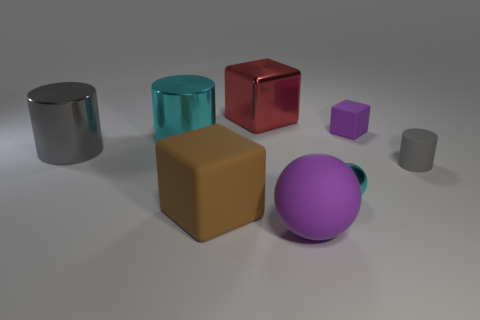Subtract all gray cylinders. How many were subtracted if there are1gray cylinders left? 1 Subtract all cyan cylinders. How many cylinders are left? 2 Subtract all brown spheres. How many gray cylinders are left? 2 Subtract all cyan cylinders. How many cylinders are left? 2 Add 2 tiny cyan cylinders. How many objects exist? 10 Subtract 1 cubes. How many cubes are left? 2 Subtract all balls. How many objects are left? 6 Add 4 large metal blocks. How many large metal blocks exist? 5 Subtract 0 yellow cylinders. How many objects are left? 8 Subtract all brown cylinders. Subtract all gray balls. How many cylinders are left? 3 